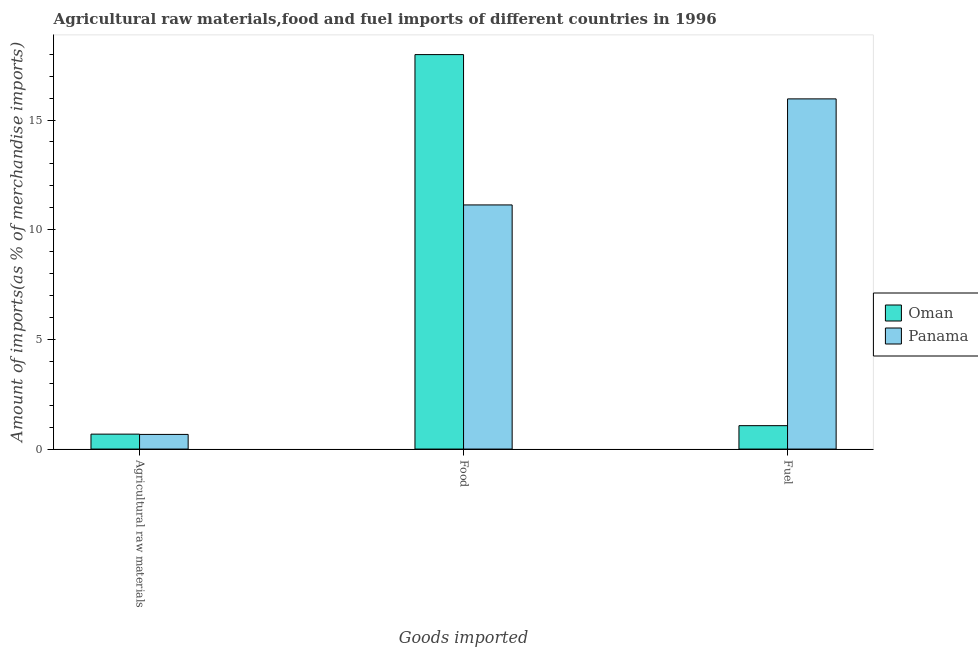What is the label of the 2nd group of bars from the left?
Give a very brief answer. Food. What is the percentage of food imports in Panama?
Keep it short and to the point. 11.13. Across all countries, what is the maximum percentage of raw materials imports?
Make the answer very short. 0.68. Across all countries, what is the minimum percentage of food imports?
Your response must be concise. 11.13. In which country was the percentage of raw materials imports maximum?
Offer a very short reply. Oman. In which country was the percentage of fuel imports minimum?
Offer a very short reply. Oman. What is the total percentage of raw materials imports in the graph?
Your answer should be very brief. 1.35. What is the difference between the percentage of food imports in Panama and that in Oman?
Provide a succinct answer. -6.85. What is the difference between the percentage of raw materials imports in Panama and the percentage of fuel imports in Oman?
Make the answer very short. -0.4. What is the average percentage of food imports per country?
Give a very brief answer. 14.56. What is the difference between the percentage of food imports and percentage of fuel imports in Oman?
Offer a terse response. 16.91. What is the ratio of the percentage of food imports in Panama to that in Oman?
Make the answer very short. 0.62. What is the difference between the highest and the second highest percentage of food imports?
Provide a succinct answer. 6.85. What is the difference between the highest and the lowest percentage of raw materials imports?
Offer a very short reply. 0.01. Is the sum of the percentage of food imports in Panama and Oman greater than the maximum percentage of raw materials imports across all countries?
Keep it short and to the point. Yes. What does the 1st bar from the left in Food represents?
Provide a short and direct response. Oman. What does the 1st bar from the right in Fuel represents?
Your answer should be very brief. Panama. How many bars are there?
Keep it short and to the point. 6. Are all the bars in the graph horizontal?
Provide a succinct answer. No. Are the values on the major ticks of Y-axis written in scientific E-notation?
Provide a succinct answer. No. Where does the legend appear in the graph?
Your answer should be compact. Center right. What is the title of the graph?
Offer a terse response. Agricultural raw materials,food and fuel imports of different countries in 1996. Does "Tajikistan" appear as one of the legend labels in the graph?
Provide a succinct answer. No. What is the label or title of the X-axis?
Give a very brief answer. Goods imported. What is the label or title of the Y-axis?
Keep it short and to the point. Amount of imports(as % of merchandise imports). What is the Amount of imports(as % of merchandise imports) of Oman in Agricultural raw materials?
Give a very brief answer. 0.68. What is the Amount of imports(as % of merchandise imports) in Panama in Agricultural raw materials?
Your response must be concise. 0.67. What is the Amount of imports(as % of merchandise imports) of Oman in Food?
Offer a very short reply. 17.98. What is the Amount of imports(as % of merchandise imports) in Panama in Food?
Your response must be concise. 11.13. What is the Amount of imports(as % of merchandise imports) in Oman in Fuel?
Offer a terse response. 1.07. What is the Amount of imports(as % of merchandise imports) in Panama in Fuel?
Provide a succinct answer. 15.96. Across all Goods imported, what is the maximum Amount of imports(as % of merchandise imports) in Oman?
Give a very brief answer. 17.98. Across all Goods imported, what is the maximum Amount of imports(as % of merchandise imports) in Panama?
Make the answer very short. 15.96. Across all Goods imported, what is the minimum Amount of imports(as % of merchandise imports) of Oman?
Provide a short and direct response. 0.68. Across all Goods imported, what is the minimum Amount of imports(as % of merchandise imports) of Panama?
Make the answer very short. 0.67. What is the total Amount of imports(as % of merchandise imports) of Oman in the graph?
Ensure brevity in your answer.  19.73. What is the total Amount of imports(as % of merchandise imports) in Panama in the graph?
Offer a very short reply. 27.76. What is the difference between the Amount of imports(as % of merchandise imports) in Oman in Agricultural raw materials and that in Food?
Provide a succinct answer. -17.3. What is the difference between the Amount of imports(as % of merchandise imports) in Panama in Agricultural raw materials and that in Food?
Offer a very short reply. -10.46. What is the difference between the Amount of imports(as % of merchandise imports) in Oman in Agricultural raw materials and that in Fuel?
Make the answer very short. -0.39. What is the difference between the Amount of imports(as % of merchandise imports) in Panama in Agricultural raw materials and that in Fuel?
Your answer should be compact. -15.3. What is the difference between the Amount of imports(as % of merchandise imports) of Oman in Food and that in Fuel?
Your answer should be compact. 16.91. What is the difference between the Amount of imports(as % of merchandise imports) in Panama in Food and that in Fuel?
Your response must be concise. -4.83. What is the difference between the Amount of imports(as % of merchandise imports) of Oman in Agricultural raw materials and the Amount of imports(as % of merchandise imports) of Panama in Food?
Your response must be concise. -10.45. What is the difference between the Amount of imports(as % of merchandise imports) of Oman in Agricultural raw materials and the Amount of imports(as % of merchandise imports) of Panama in Fuel?
Offer a terse response. -15.28. What is the difference between the Amount of imports(as % of merchandise imports) in Oman in Food and the Amount of imports(as % of merchandise imports) in Panama in Fuel?
Your response must be concise. 2.02. What is the average Amount of imports(as % of merchandise imports) in Oman per Goods imported?
Offer a terse response. 6.58. What is the average Amount of imports(as % of merchandise imports) in Panama per Goods imported?
Ensure brevity in your answer.  9.25. What is the difference between the Amount of imports(as % of merchandise imports) of Oman and Amount of imports(as % of merchandise imports) of Panama in Agricultural raw materials?
Make the answer very short. 0.01. What is the difference between the Amount of imports(as % of merchandise imports) in Oman and Amount of imports(as % of merchandise imports) in Panama in Food?
Provide a short and direct response. 6.85. What is the difference between the Amount of imports(as % of merchandise imports) in Oman and Amount of imports(as % of merchandise imports) in Panama in Fuel?
Your answer should be compact. -14.9. What is the ratio of the Amount of imports(as % of merchandise imports) in Oman in Agricultural raw materials to that in Food?
Offer a terse response. 0.04. What is the ratio of the Amount of imports(as % of merchandise imports) in Panama in Agricultural raw materials to that in Food?
Keep it short and to the point. 0.06. What is the ratio of the Amount of imports(as % of merchandise imports) of Oman in Agricultural raw materials to that in Fuel?
Provide a short and direct response. 0.64. What is the ratio of the Amount of imports(as % of merchandise imports) in Panama in Agricultural raw materials to that in Fuel?
Provide a short and direct response. 0.04. What is the ratio of the Amount of imports(as % of merchandise imports) in Oman in Food to that in Fuel?
Provide a succinct answer. 16.84. What is the ratio of the Amount of imports(as % of merchandise imports) in Panama in Food to that in Fuel?
Provide a succinct answer. 0.7. What is the difference between the highest and the second highest Amount of imports(as % of merchandise imports) in Oman?
Give a very brief answer. 16.91. What is the difference between the highest and the second highest Amount of imports(as % of merchandise imports) in Panama?
Provide a succinct answer. 4.83. What is the difference between the highest and the lowest Amount of imports(as % of merchandise imports) in Oman?
Your answer should be compact. 17.3. What is the difference between the highest and the lowest Amount of imports(as % of merchandise imports) in Panama?
Your answer should be compact. 15.3. 